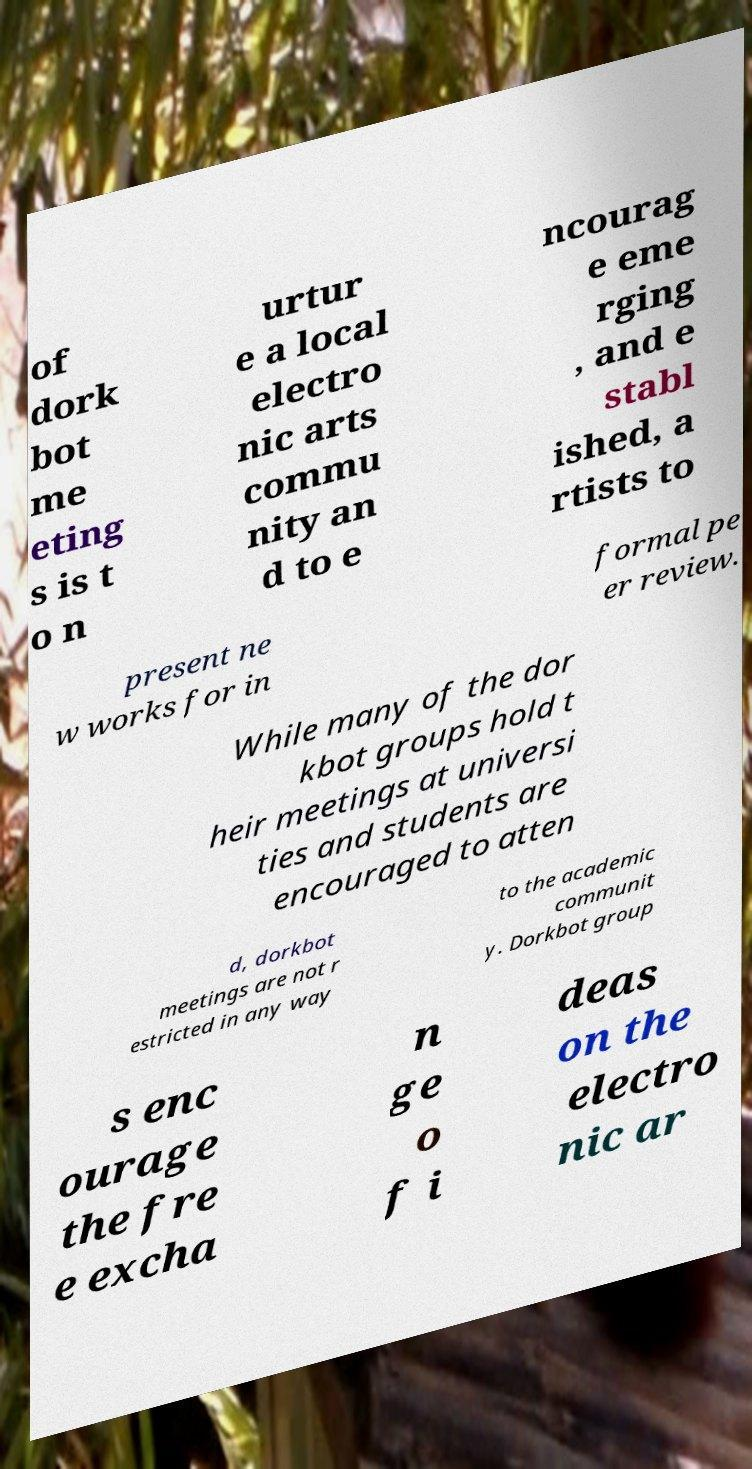Can you read and provide the text displayed in the image?This photo seems to have some interesting text. Can you extract and type it out for me? of dork bot me eting s is t o n urtur e a local electro nic arts commu nity an d to e ncourag e eme rging , and e stabl ished, a rtists to present ne w works for in formal pe er review. While many of the dor kbot groups hold t heir meetings at universi ties and students are encouraged to atten d, dorkbot meetings are not r estricted in any way to the academic communit y. Dorkbot group s enc ourage the fre e excha n ge o f i deas on the electro nic ar 